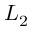Convert formula to latex. <formula><loc_0><loc_0><loc_500><loc_500>L _ { 2 }</formula> 